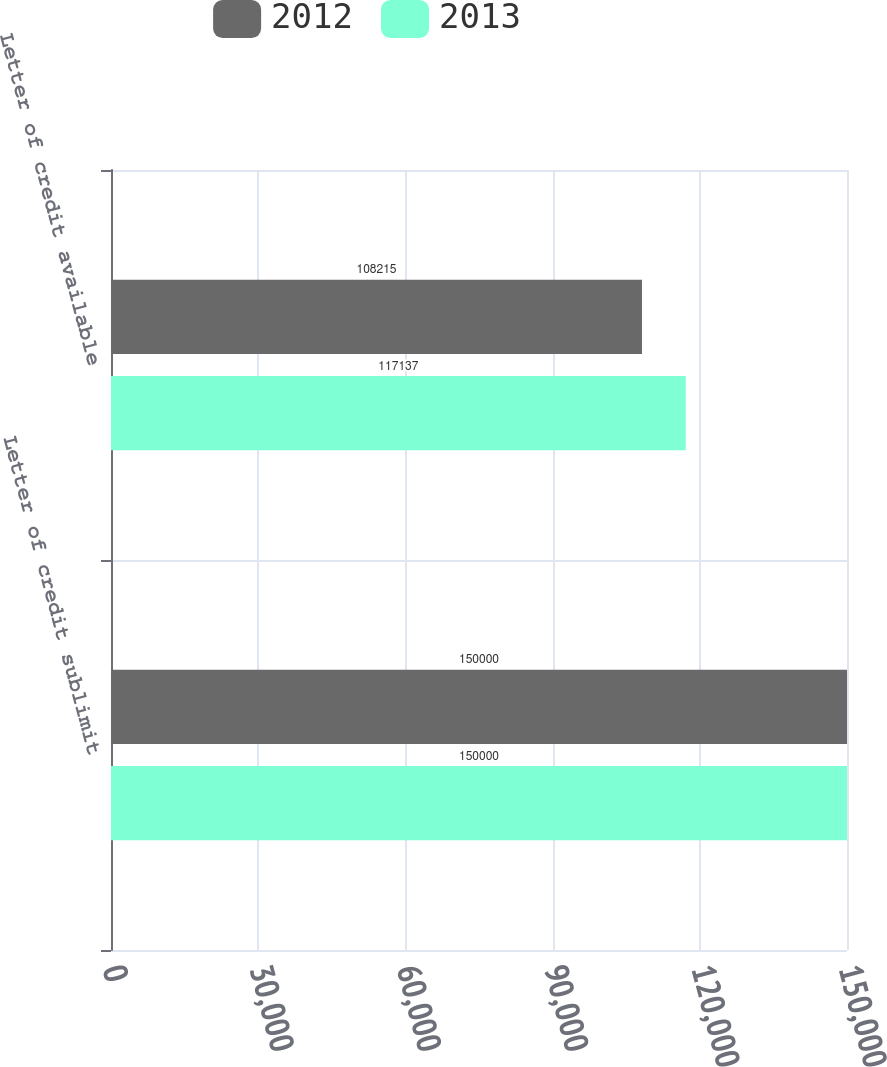Convert chart. <chart><loc_0><loc_0><loc_500><loc_500><stacked_bar_chart><ecel><fcel>Letter of credit sublimit<fcel>Letter of credit available<nl><fcel>2012<fcel>150000<fcel>108215<nl><fcel>2013<fcel>150000<fcel>117137<nl></chart> 